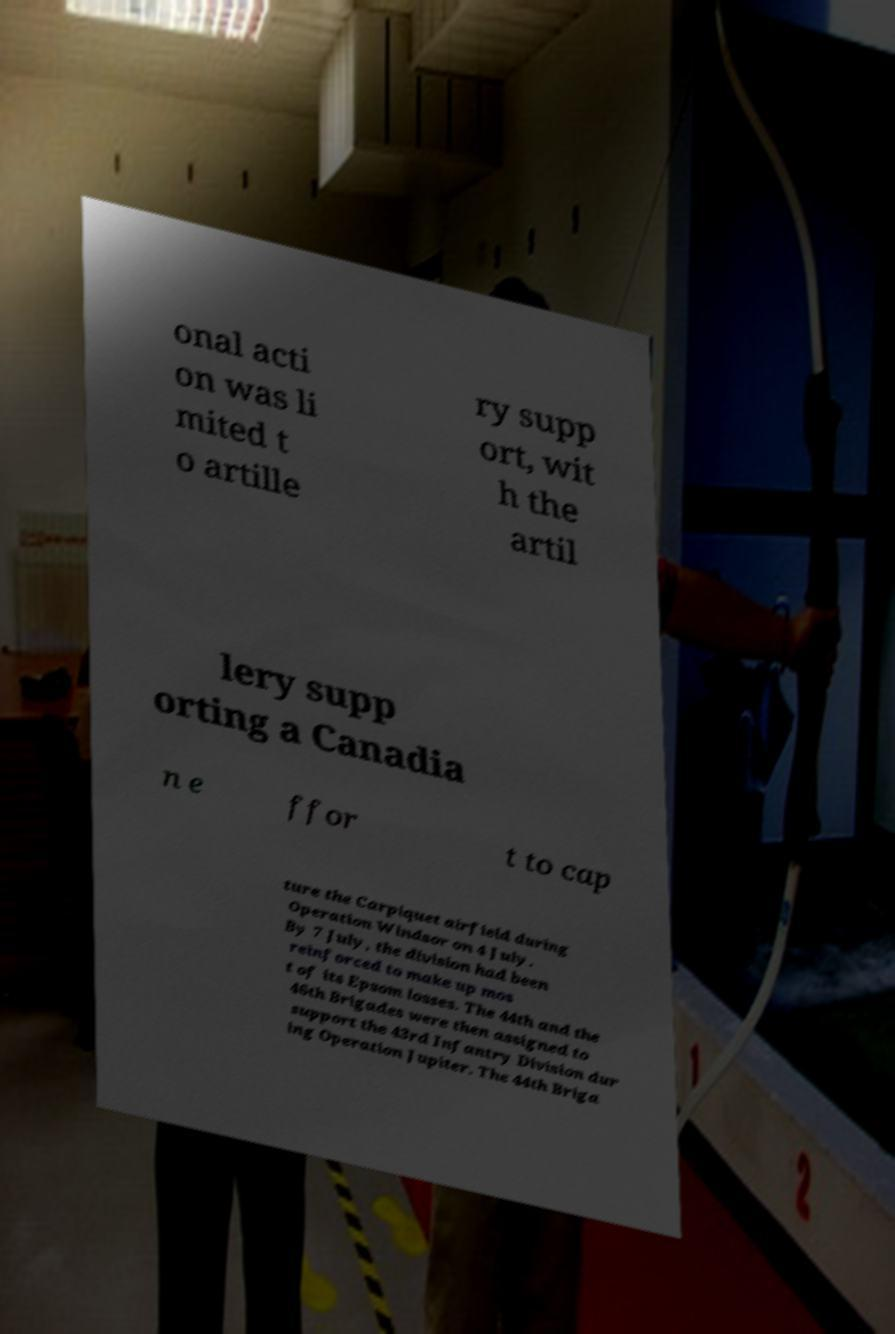Please read and relay the text visible in this image. What does it say? onal acti on was li mited t o artille ry supp ort, wit h the artil lery supp orting a Canadia n e ffor t to cap ture the Carpiquet airfield during Operation Windsor on 4 July. By 7 July, the division had been reinforced to make up mos t of its Epsom losses. The 44th and the 46th Brigades were then assigned to support the 43rd Infantry Division dur ing Operation Jupiter. The 44th Briga 